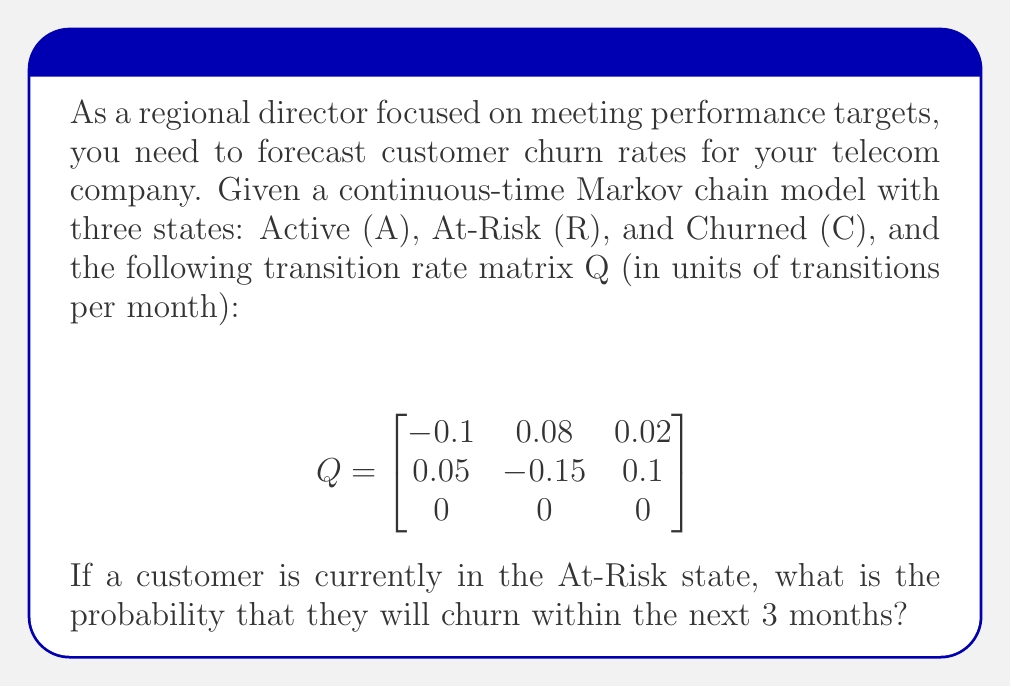Help me with this question. To solve this problem, we need to use the continuous-time Markov chain theory and calculate the transition probability matrix for the given time interval. Here's the step-by-step solution:

1. The transition probability matrix P(t) for a continuous-time Markov chain is given by:

   $P(t) = e^{Qt}$

   where Q is the transition rate matrix and t is the time interval.

2. In this case, t = 3 months. We need to calculate $e^{3Q}$.

3. To compute $e^{3Q}$, we can use the matrix exponential series:

   $e^{3Q} = I + 3Q + \frac{(3Q)^2}{2!} + \frac{(3Q)^3}{3!} + ...$

4. For practical purposes, we can approximate this series by taking the first few terms. Let's use the first three terms:

   $P(3) \approx I + 3Q + \frac{9Q^2}{2}$

5. Calculate 3Q:
   $3Q = \begin{bmatrix}
   -0.3 & 0.24 & 0.06 \\
   0.15 & -0.45 & 0.3 \\
   0 & 0 & 0
   \end{bmatrix}$

6. Calculate $\frac{9Q^2}{2}$:
   $\frac{9Q^2}{2} = \begin{bmatrix}
   0.0585 & -0.081 & 0.0225 \\
   -0.054 & 0.1215 & -0.0675 \\
   0 & 0 & 0
   \end{bmatrix}$

7. Sum up the matrices:
   $P(3) \approx \begin{bmatrix}
   1 & 0 & 0 \\
   0 & 1 & 0 \\
   0 & 0 & 1
   \end{bmatrix} + 
   \begin{bmatrix}
   -0.3 & 0.24 & 0.06 \\
   0.15 & -0.45 & 0.3 \\
   0 & 0 & 0
   \end{bmatrix} +
   \begin{bmatrix}
   0.0585 & -0.081 & 0.0225 \\
   -0.054 & 0.1215 & -0.0675 \\
   0 & 0 & 0
   \end{bmatrix}$

8. Simplify:
   $P(3) \approx \begin{bmatrix}
   0.7585 & 0.159 & 0.0825 \\
   0.096 & 0.6715 & 0.2325 \\
   0 & 0 & 1
   \end{bmatrix}$

9. The probability of churning within 3 months, given that the customer is currently in the At-Risk state, is the entry in the second row, third column of P(3).
Answer: 0.2325 or 23.25% 